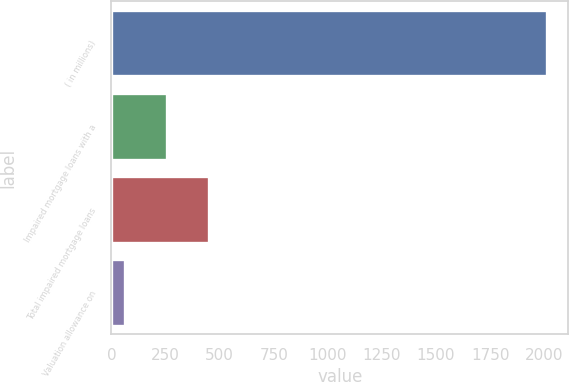Convert chart to OTSL. <chart><loc_0><loc_0><loc_500><loc_500><bar_chart><fcel>( in millions)<fcel>Impaired mortgage loans with a<fcel>Total impaired mortgage loans<fcel>Valuation allowance on<nl><fcel>2011<fcel>257.8<fcel>452.6<fcel>63<nl></chart> 